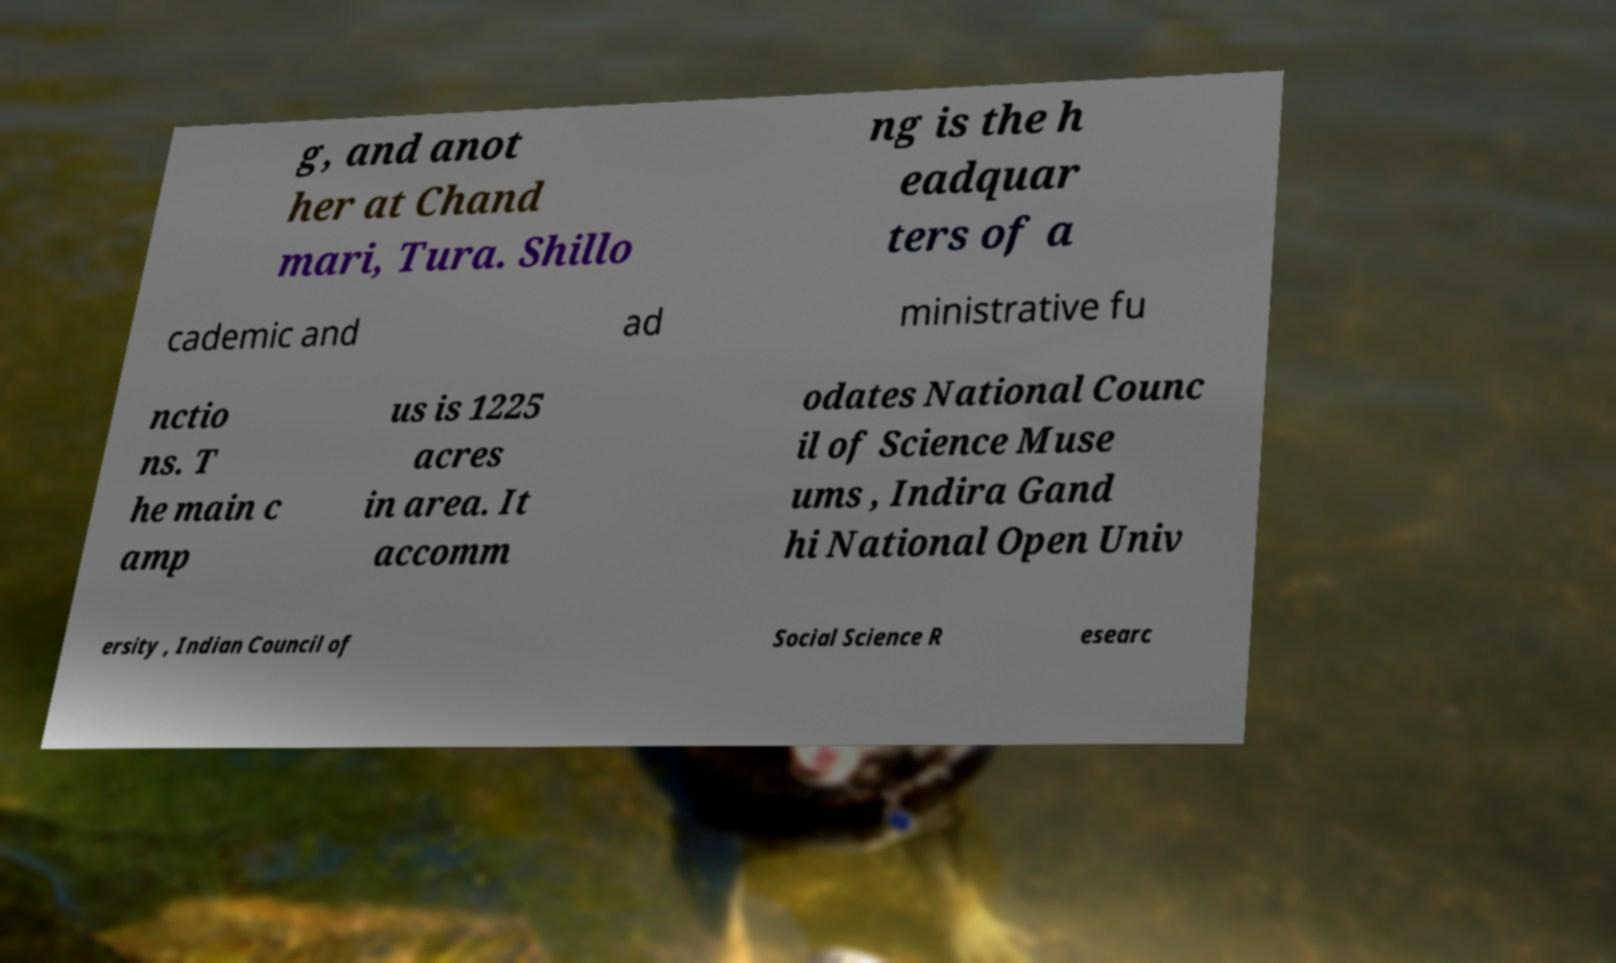Can you read and provide the text displayed in the image?This photo seems to have some interesting text. Can you extract and type it out for me? g, and anot her at Chand mari, Tura. Shillo ng is the h eadquar ters of a cademic and ad ministrative fu nctio ns. T he main c amp us is 1225 acres in area. It accomm odates National Counc il of Science Muse ums , Indira Gand hi National Open Univ ersity , Indian Council of Social Science R esearc 